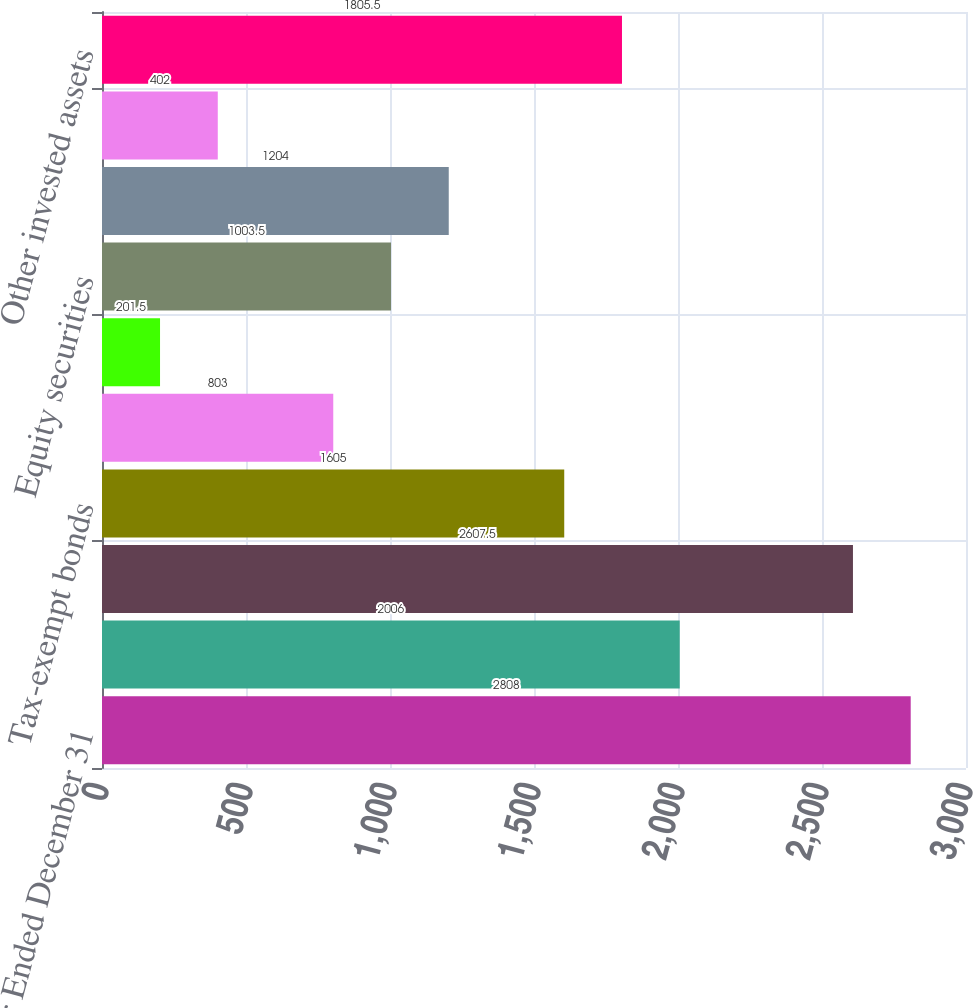<chart> <loc_0><loc_0><loc_500><loc_500><bar_chart><fcel>Year Ended December 31<fcel>US Government bonds<fcel>Corporate and other taxable<fcel>Tax-exempt bonds<fcel>Asset-backed bonds<fcel>Total fixed maturity<fcel>Equity securities<fcel>Derivative securities<fcel>Short term investments<fcel>Other invested assets<nl><fcel>2808<fcel>2006<fcel>2607.5<fcel>1605<fcel>803<fcel>201.5<fcel>1003.5<fcel>1204<fcel>402<fcel>1805.5<nl></chart> 